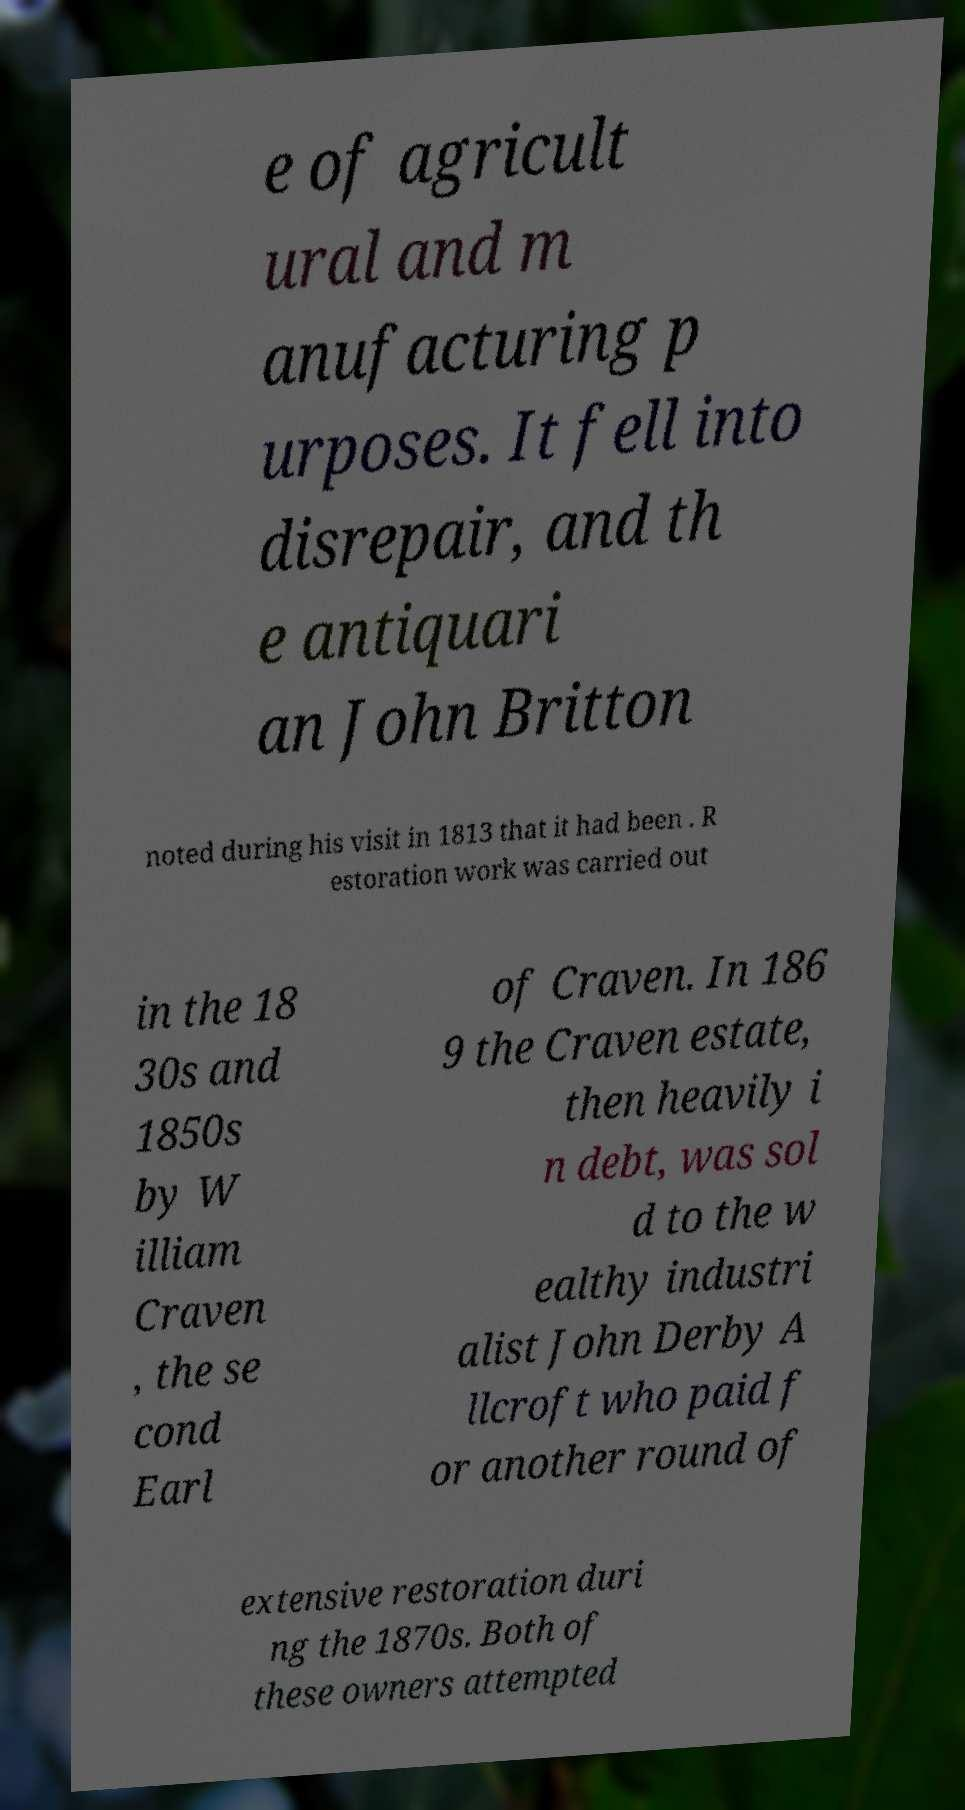Please read and relay the text visible in this image. What does it say? e of agricult ural and m anufacturing p urposes. It fell into disrepair, and th e antiquari an John Britton noted during his visit in 1813 that it had been . R estoration work was carried out in the 18 30s and 1850s by W illiam Craven , the se cond Earl of Craven. In 186 9 the Craven estate, then heavily i n debt, was sol d to the w ealthy industri alist John Derby A llcroft who paid f or another round of extensive restoration duri ng the 1870s. Both of these owners attempted 